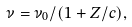<formula> <loc_0><loc_0><loc_500><loc_500>\nu = \nu _ { 0 } / ( 1 + Z / c ) ,</formula> 